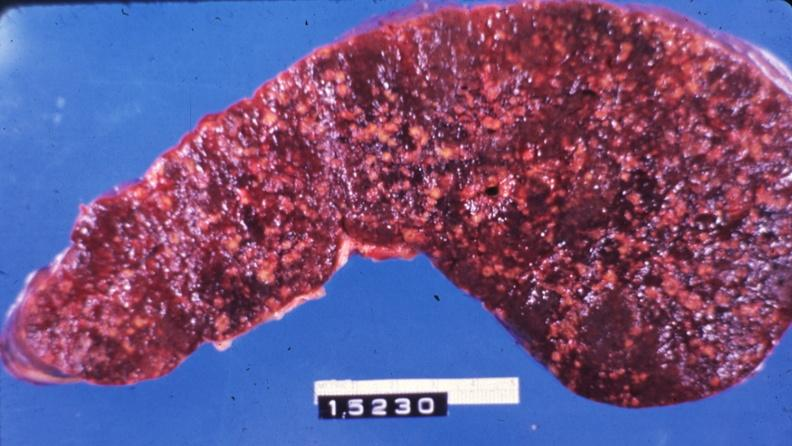how does this image show slice of spleen?
Answer the question using a single word or phrase. With multiple nodules 